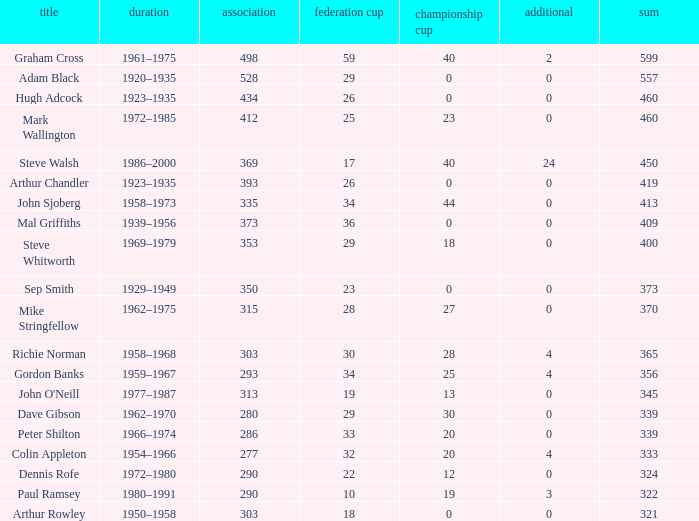Help me parse the entirety of this table. {'header': ['title', 'duration', 'association', 'federation cup', 'championship cup', 'additional', 'sum'], 'rows': [['Graham Cross', '1961–1975', '498', '59', '40', '2', '599'], ['Adam Black', '1920–1935', '528', '29', '0', '0', '557'], ['Hugh Adcock', '1923–1935', '434', '26', '0', '0', '460'], ['Mark Wallington', '1972–1985', '412', '25', '23', '0', '460'], ['Steve Walsh', '1986–2000', '369', '17', '40', '24', '450'], ['Arthur Chandler', '1923–1935', '393', '26', '0', '0', '419'], ['John Sjoberg', '1958–1973', '335', '34', '44', '0', '413'], ['Mal Griffiths', '1939–1956', '373', '36', '0', '0', '409'], ['Steve Whitworth', '1969–1979', '353', '29', '18', '0', '400'], ['Sep Smith', '1929–1949', '350', '23', '0', '0', '373'], ['Mike Stringfellow', '1962–1975', '315', '28', '27', '0', '370'], ['Richie Norman', '1958–1968', '303', '30', '28', '4', '365'], ['Gordon Banks', '1959–1967', '293', '34', '25', '4', '356'], ["John O'Neill", '1977–1987', '313', '19', '13', '0', '345'], ['Dave Gibson', '1962–1970', '280', '29', '30', '0', '339'], ['Peter Shilton', '1966–1974', '286', '33', '20', '0', '339'], ['Colin Appleton', '1954–1966', '277', '32', '20', '4', '333'], ['Dennis Rofe', '1972–1980', '290', '22', '12', '0', '324'], ['Paul Ramsey', '1980–1991', '290', '10', '19', '3', '322'], ['Arthur Rowley', '1950–1958', '303', '18', '0', '0', '321']]} What is the average number of FA cups Steve Whitworth, who has less than 400 total, has? None. 